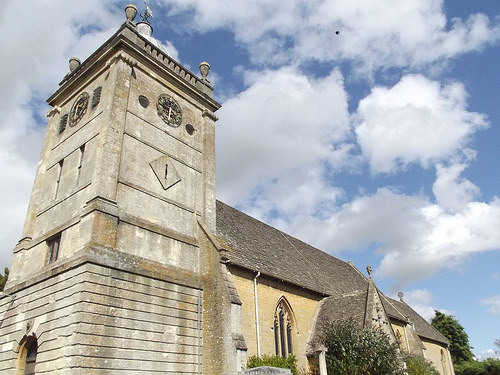<image>
Is the sky behind the building? Yes. From this viewpoint, the sky is positioned behind the building, with the building partially or fully occluding the sky. 